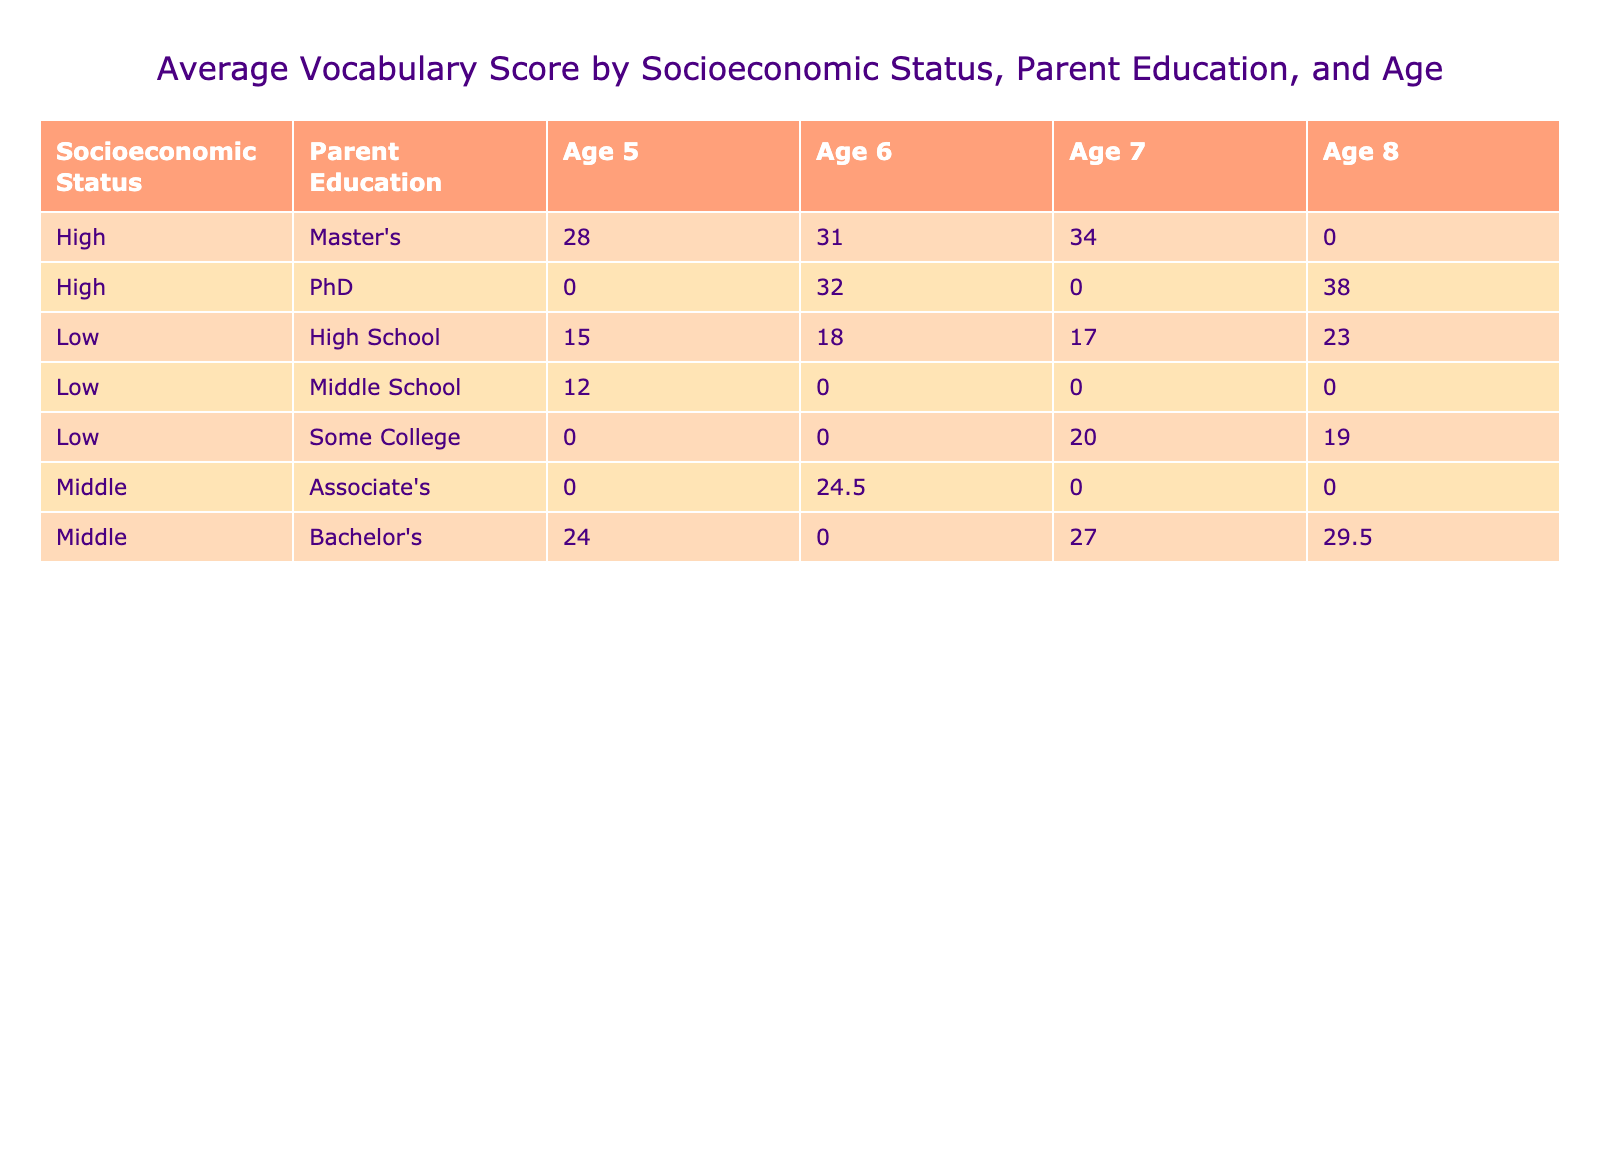What is the average vocabulary score for children aged 5 from high socioeconomic backgrounds? Looking at the 'Age 5' column under the 'High' socioeconomic status, the average vocabulary score is 28 (from Student_IDs 3) since it's the only entry for this combination.
Answer: 28 What is the average vocabulary score for children aged 6 from middle socioeconomic backgrounds? For children aged 6 in the middle socioeconomic background, the entries are from Student_ID 5 and Student_ID 14. Their vocabulary scores are 25 and 24, respectively. The average is (25 + 24) / 2 = 24.5.
Answer: 24.5 Does any child from a low socioeconomic background have a vocabulary score of 4 or higher? Reviewing the data for the low socioeconomic status, the maximum vocabulary score observed is 3 (found in Student_IDs 1, 4, 7, 10, and 13). Thus, no child meets the criteria of having a score of 4 or higher.
Answer: No What is the difference in average vocabulary scores between children with high parent education and those with low parent education for age 7? For high parent education at age 7, the scores are from Student_ID 9 (35) and Student_ID 15 (33), giving an average of (35 + 33) / 2 = 34. For low parent education, the score from Student_ID 19 is 17. The difference is 34 - 17 = 17.
Answer: 17 Which socioeconomic group has the highest average vocabulary score in age 8, and what is that score? Checking the 'Age 8' column, the scores are for high (38), middle (29), and low (19). The highest average score is 38 from the high socioeconomic group.
Answer: High; 38 What is the total vocabulary score for children aged 6, regardless of their socioeconomic background? The vocabulary scores for age 6 are from Student_IDs 5 (25), 6 (32), 14 (24), and 18 (31). Adding these up gives 25 + 32 + 24 + 31 = 112.
Answer: 112 Is there a child from a suburban school district with a vocabulary score of 30 or higher? Checking the suburban district entries, Student_ID 9 has a score of 35, and Student_ID 11 has a score of 30. Therefore, yes, there are children with scores of 30 or higher from the suburban district.
Answer: Yes What is the average vocabulary score for children aged 7 from rural backgrounds compared to those from urban backgrounds? For rural children aged 7 (from Student_ID 8), the score is 27, while urban children (from Student_IDs 7 and 19) have scores of 20 and 17. The average for rural is 27, and for urban, it is (20 + 17) / 2 = 18.5. The rural average is higher.
Answer: Rural; 27; Urban; 18.5 